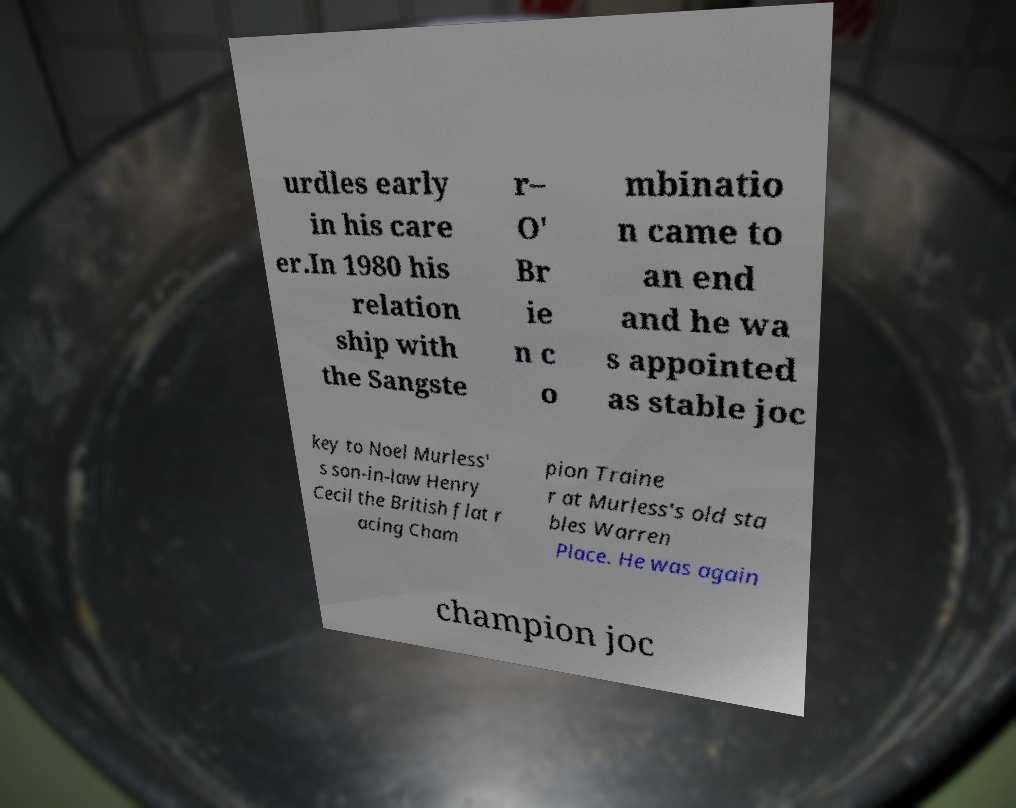Please identify and transcribe the text found in this image. urdles early in his care er.In 1980 his relation ship with the Sangste r– O' Br ie n c o mbinatio n came to an end and he wa s appointed as stable joc key to Noel Murless' s son-in-law Henry Cecil the British flat r acing Cham pion Traine r at Murless's old sta bles Warren Place. He was again champion joc 